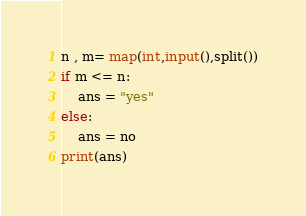Convert code to text. <code><loc_0><loc_0><loc_500><loc_500><_Python_>n , m= map(int,input(),split())
if m <= n:
    ans = "yes"
else:
    ans = no
print(ans)</code> 